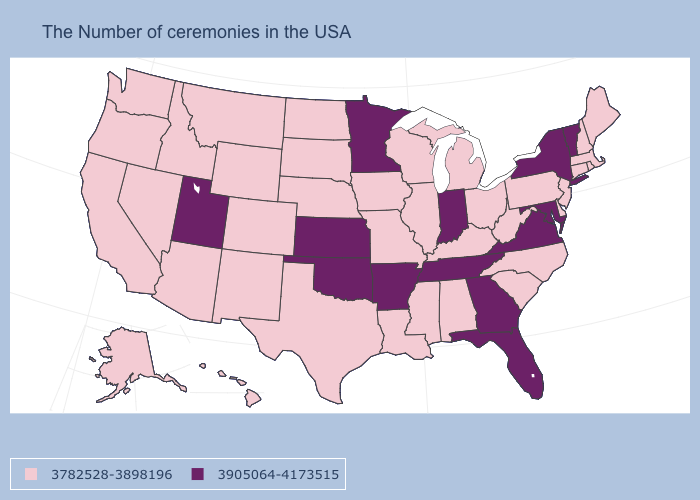Does North Carolina have the lowest value in the USA?
Keep it brief. Yes. Which states have the highest value in the USA?
Quick response, please. Vermont, New York, Maryland, Virginia, Florida, Georgia, Indiana, Tennessee, Arkansas, Minnesota, Kansas, Oklahoma, Utah. Name the states that have a value in the range 3905064-4173515?
Concise answer only. Vermont, New York, Maryland, Virginia, Florida, Georgia, Indiana, Tennessee, Arkansas, Minnesota, Kansas, Oklahoma, Utah. What is the highest value in the USA?
Give a very brief answer. 3905064-4173515. Is the legend a continuous bar?
Concise answer only. No. Does Wisconsin have the highest value in the MidWest?
Keep it brief. No. Name the states that have a value in the range 3905064-4173515?
Keep it brief. Vermont, New York, Maryland, Virginia, Florida, Georgia, Indiana, Tennessee, Arkansas, Minnesota, Kansas, Oklahoma, Utah. Does New York have the highest value in the Northeast?
Answer briefly. Yes. Does New Hampshire have the highest value in the Northeast?
Be succinct. No. Name the states that have a value in the range 3905064-4173515?
Quick response, please. Vermont, New York, Maryland, Virginia, Florida, Georgia, Indiana, Tennessee, Arkansas, Minnesota, Kansas, Oklahoma, Utah. Among the states that border Idaho , does Wyoming have the lowest value?
Keep it brief. Yes. Is the legend a continuous bar?
Write a very short answer. No. 